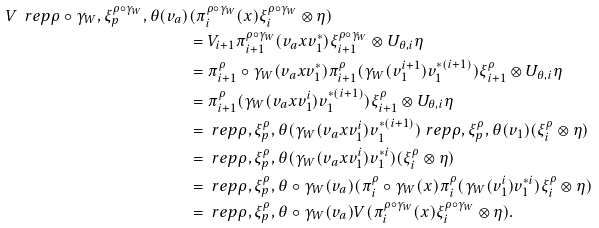Convert formula to latex. <formula><loc_0><loc_0><loc_500><loc_500>V \ r e p { \rho \circ \gamma _ { W } , \xi ^ { \rho \circ \gamma _ { W } } _ { p } , \theta } ( v _ { a } ) & ( \pi ^ { \rho \circ \gamma _ { W } } _ { i } ( x ) \xi ^ { \rho \circ \gamma _ { W } } _ { i } \otimes \eta ) \\ & = V _ { i + 1 } \pi ^ { \rho \circ \gamma _ { W } } _ { i + 1 } ( v _ { a } x v _ { 1 } ^ { * } ) \xi ^ { \rho \circ \gamma _ { W } } _ { i + 1 } \otimes U _ { \theta , i } \eta \\ & = \pi ^ { \rho } _ { i + 1 } \circ \gamma _ { W } ( v _ { a } x v _ { 1 } ^ { * } ) \pi ^ { \rho } _ { i + 1 } ( \gamma _ { W } ( v _ { 1 } ^ { i + 1 } ) v _ { 1 } ^ { * ( i + 1 ) } ) \xi ^ { \rho } _ { i + 1 } \otimes U _ { \theta , i } \eta \\ & = \pi ^ { \rho } _ { i + 1 } ( \gamma _ { W } ( v _ { a } x v _ { 1 } ^ { i } ) v _ { 1 } ^ { * ( i + 1 ) } ) \xi ^ { \rho } _ { i + 1 } \otimes U _ { \theta , i } \eta \\ & = \ r e p { \rho , \xi ^ { \rho } _ { p } , \theta } ( \gamma _ { W } ( v _ { a } x v _ { 1 } ^ { i } ) v _ { 1 } ^ { * ( i + 1 ) } ) \ r e p { \rho , \xi ^ { \rho } _ { p } , \theta } ( v _ { 1 } ) ( \xi ^ { \rho } _ { i } \otimes \eta ) \\ & = \ r e p { \rho , \xi ^ { \rho } _ { p } , \theta } ( \gamma _ { W } ( v _ { a } x v _ { 1 } ^ { i } ) v _ { 1 } ^ { * i } ) ( \xi ^ { \rho } _ { i } \otimes \eta ) \\ & = \ r e p { \rho , \xi ^ { \rho } _ { p } , \theta } \circ \gamma _ { W } ( v _ { a } ) ( \pi ^ { \rho } _ { i } \circ \gamma _ { W } ( x ) \pi ^ { \rho } _ { i } ( \gamma _ { W } ( v _ { 1 } ^ { i } ) v _ { 1 } ^ { * i } ) \xi ^ { \rho } _ { i } \otimes \eta ) \\ & = \ r e p { \rho , \xi ^ { \rho } _ { p } , \theta } \circ \gamma _ { W } ( v _ { a } ) V ( \pi ^ { \rho \circ \gamma _ { W } } _ { i } ( x ) \xi ^ { \rho \circ \gamma _ { W } } _ { i } \otimes \eta ) .</formula> 